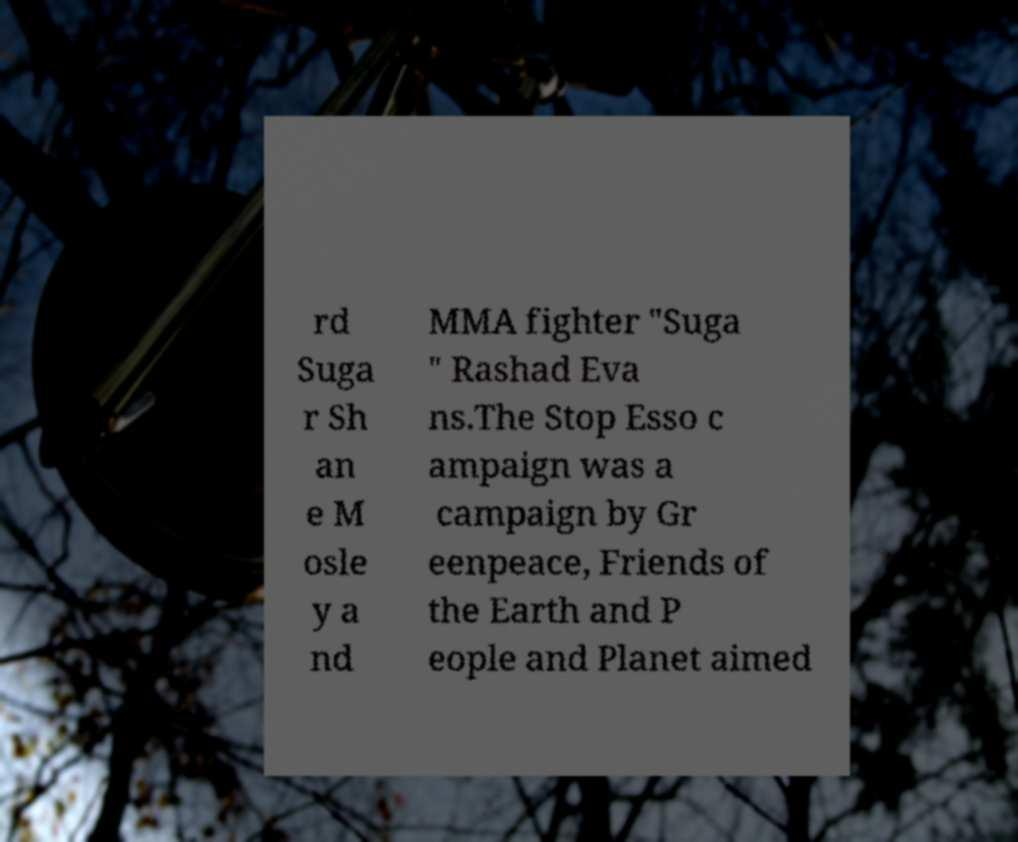What messages or text are displayed in this image? I need them in a readable, typed format. rd Suga r Sh an e M osle y a nd MMA fighter "Suga " Rashad Eva ns.The Stop Esso c ampaign was a campaign by Gr eenpeace, Friends of the Earth and P eople and Planet aimed 